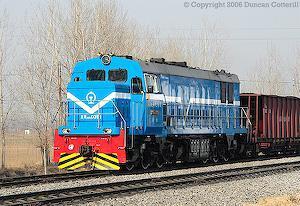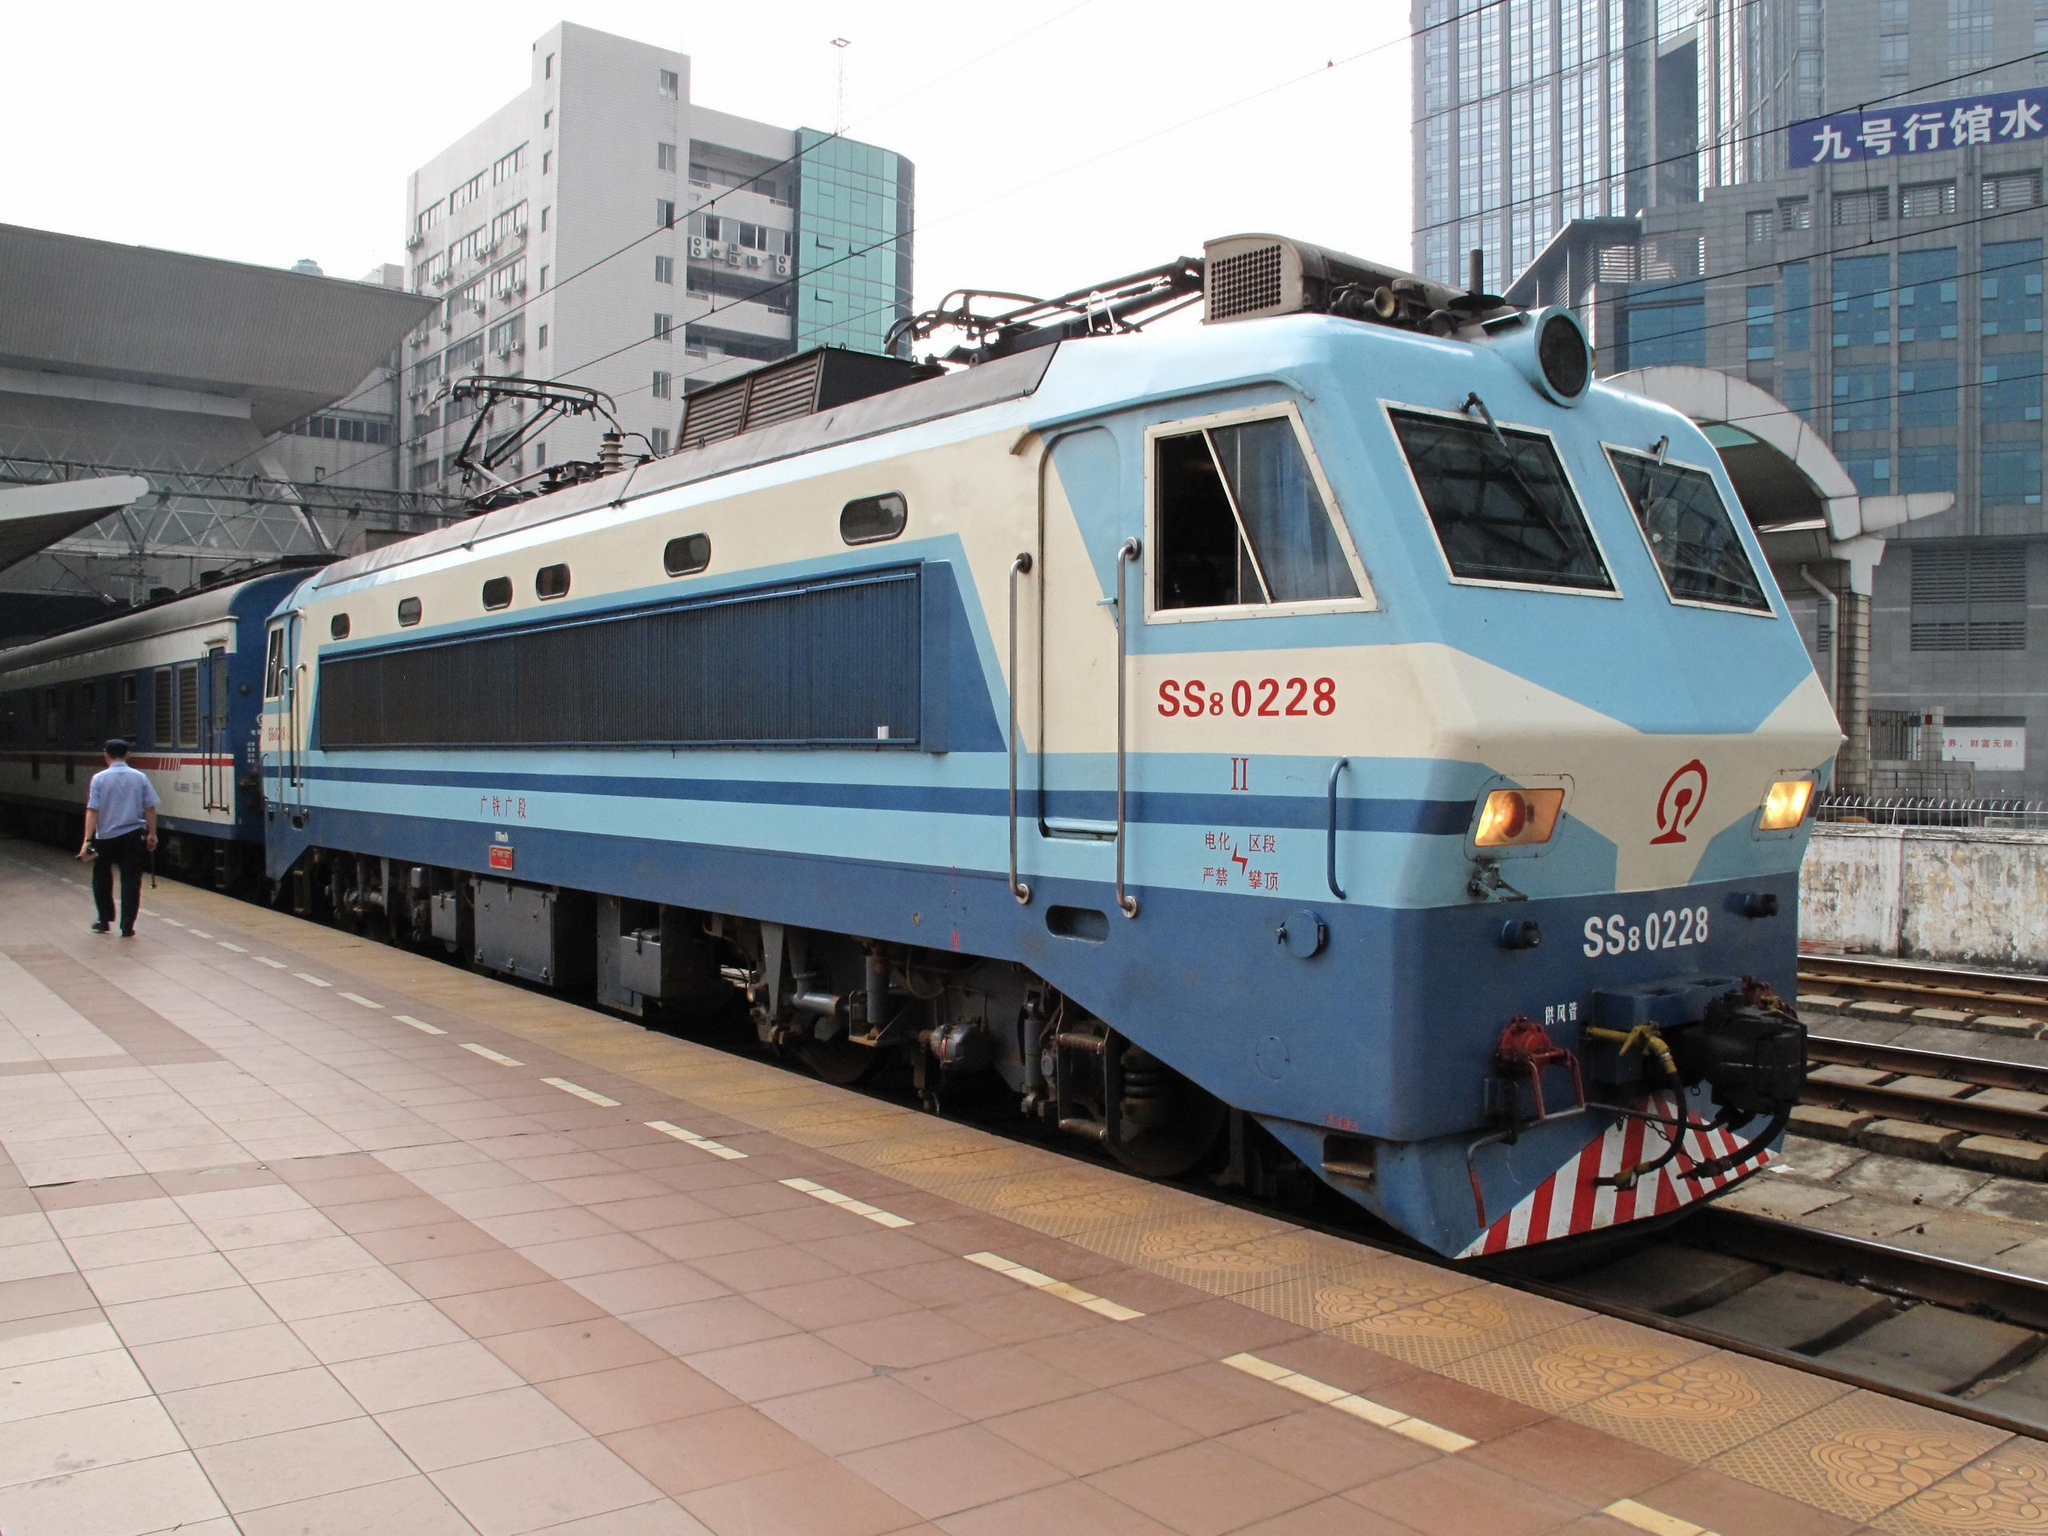The first image is the image on the left, the second image is the image on the right. For the images shown, is this caption "The trains in the left and right images do not head in the same left or right direction, and at least one train is blue with a sloped front." true? Answer yes or no. Yes. The first image is the image on the left, the second image is the image on the right. Analyze the images presented: Is the assertion "The right image contains a train that is predominately blue." valid? Answer yes or no. Yes. 